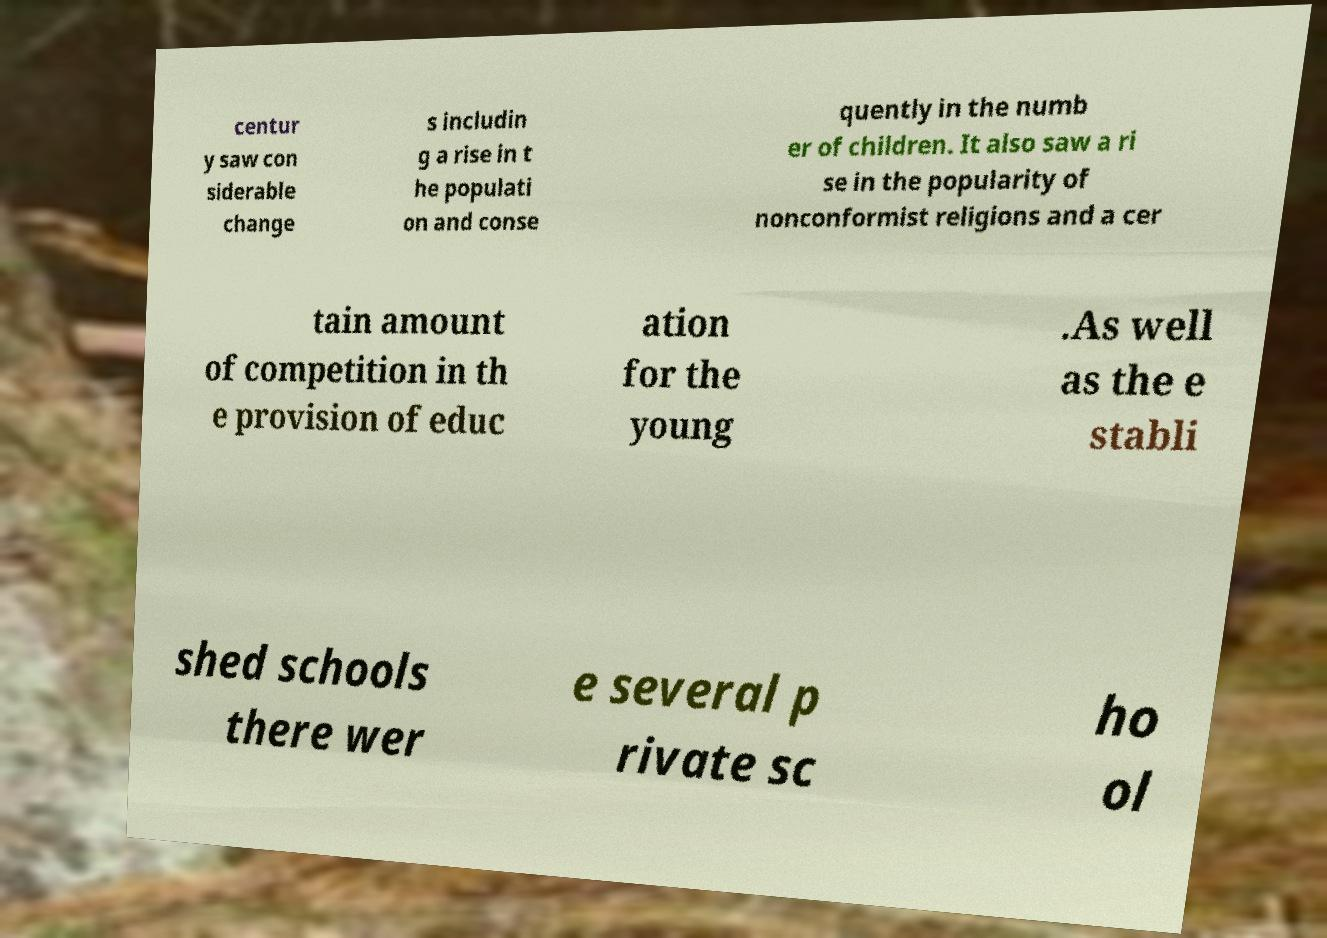There's text embedded in this image that I need extracted. Can you transcribe it verbatim? centur y saw con siderable change s includin g a rise in t he populati on and conse quently in the numb er of children. It also saw a ri se in the popularity of nonconformist religions and a cer tain amount of competition in th e provision of educ ation for the young .As well as the e stabli shed schools there wer e several p rivate sc ho ol 